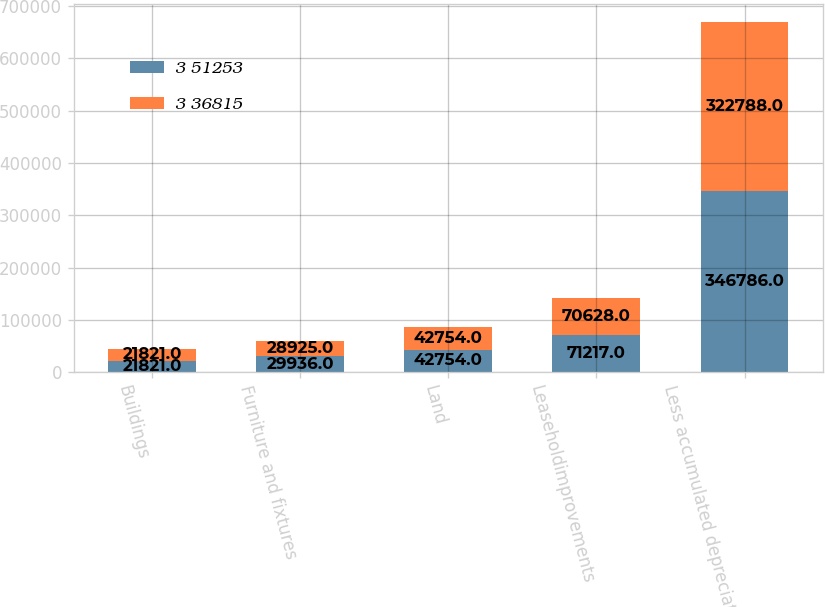<chart> <loc_0><loc_0><loc_500><loc_500><stacked_bar_chart><ecel><fcel>Buildings<fcel>Furniture and fixtures<fcel>Land<fcel>Leaseholdimprovements<fcel>Less accumulated depreciation<nl><fcel>3 51253<fcel>21821<fcel>29936<fcel>42754<fcel>71217<fcel>346786<nl><fcel>3 36815<fcel>21821<fcel>28925<fcel>42754<fcel>70628<fcel>322788<nl></chart> 